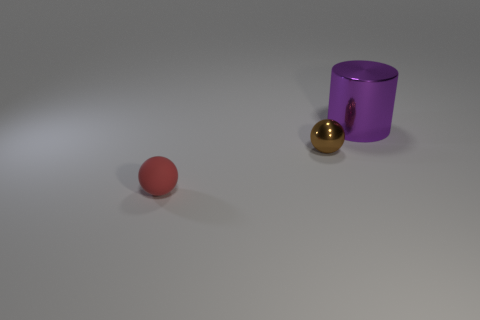Is there anything else that is the same material as the tiny red ball?
Offer a terse response. No. What is the shape of the metallic thing behind the shiny thing that is in front of the large purple shiny thing?
Your answer should be compact. Cylinder. There is a large purple shiny object; does it have the same shape as the tiny object to the right of the red sphere?
Your answer should be compact. No. What is the color of the other rubber thing that is the same size as the brown object?
Your response must be concise. Red. Are there fewer small brown metal spheres that are behind the metal sphere than tiny brown shiny spheres that are on the left side of the purple shiny thing?
Your answer should be very brief. Yes. What shape is the metallic thing in front of the thing that is to the right of the small thing right of the small red rubber ball?
Make the answer very short. Sphere. How many metal objects are either green things or spheres?
Keep it short and to the point. 1. The thing in front of the small thing that is behind the tiny object that is in front of the metallic sphere is what color?
Ensure brevity in your answer.  Red. There is a small metallic thing that is the same shape as the tiny rubber thing; what is its color?
Give a very brief answer. Brown. Is there anything else that is the same color as the tiny shiny ball?
Your answer should be very brief. No. 